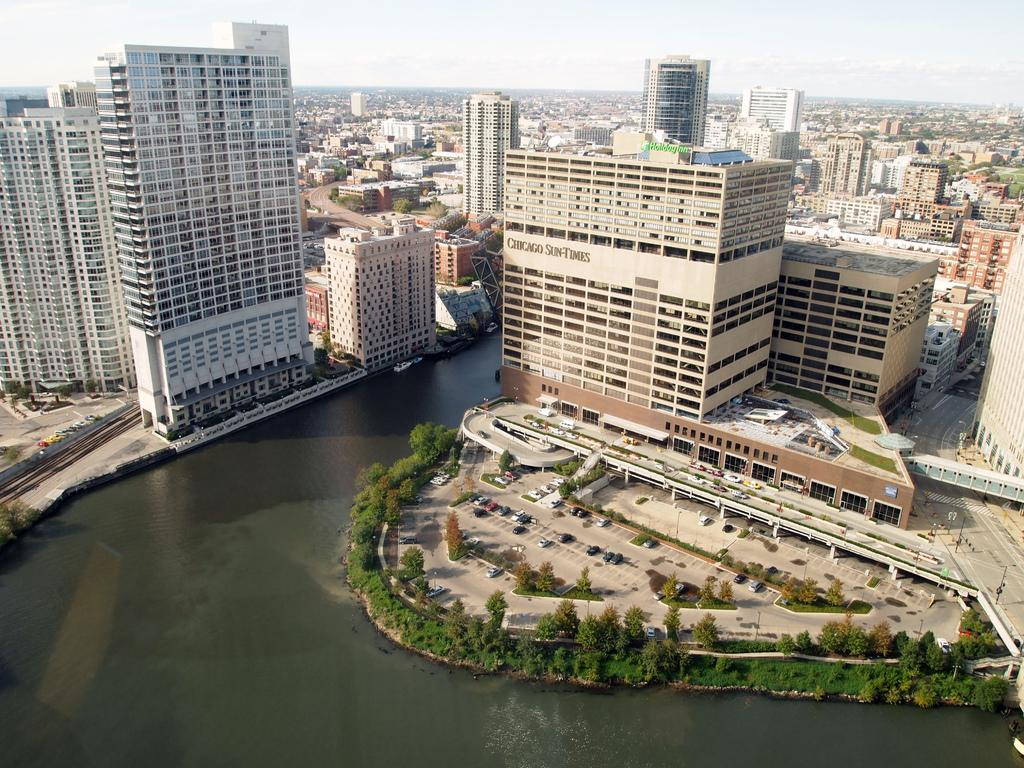What types of structures can be seen in the image? There are multiple buildings in the image. What other natural elements are present in the image? There are multiple trees in the image. What types of man-made objects can be seen in the image? There are vehicles in the image. What type of transportation infrastructure is visible in the image? There are roads visible in the image. What type of natural feature is present in the image? There is water present in the image. What type of card is being used to poison the water in the image? There is no card or poison present in the image. What type of button is being used to control the vehicles in the image? There is no button present in the image, and the vehicles are not being controlled by any visible buttons. 